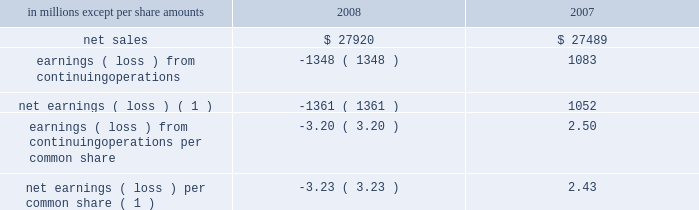The following unaudited pro forma information for the years ended december 31 , 2008 and 2007 pres- ents the results of operations of international paper as if the cbpr and central lewmar acquisitions , and the luiz antonio asset exchange , had occurred on january 1 , 2007 .
This pro forma information does not purport to represent international paper 2019s actual results of operations if the transactions described above would have occurred on january 1 , 2007 , nor is it necessarily indicative of future results .
In millions , except per share amounts 2008 2007 .
Earnings ( loss ) from continuing operations per common share ( 3.20 ) 2.50 net earnings ( loss ) per common share ( 1 ) ( 3.23 ) 2.43 ( 1 ) attributable to international paper company common share- holders .
Joint ventures in october 2007 , international paper and ilim holding s.a .
Announced the completion of the formation of a 50:50 joint venture to operate in russia as ilim group .
To form the joint venture , international paper purchased 50% ( 50 % ) of ilim holding s.a .
( ilim ) for approx- imately $ 620 million , including $ 545 million in cash and $ 75 million of notes payable , and contributed an additional $ 21 million in 2008 .
The company 2019s investment in ilim totaled approximately $ 465 mil- lion at december 31 , 2009 , which is approximately $ 190 million higher than the company 2019s share of the underlying net assets of ilim .
This basis difference primarily consists of the estimated fair value write-up of ilim plant , property and equipment of $ 150 million that is being amortized as a reduction of reported net income over the estimated remaining useful lives of the related assets , goodwill of $ 90 million and other basis differences of $ 50 million , including deferred taxes .
A key element of the proposed joint venture strategy is a long-term investment program in which the joint venture will invest , through cash from operations and additional borrowings by the joint venture , approximately $ 1.5 billion in ilim 2019s three mills over approximately five years .
This planned investment in the russian pulp and paper industry will be used to upgrade equipment , increase production capacity and allow for new high-value uncoated paper , pulp and corrugated packaging product development .
This capital expansion strategy is expected to be ini- tiated in the second half of 2010 , subject to ilim obtaining financing sufficient to fund the project .
Note 7 businesses held for sale , divestitures and impairments discontinued operations 2008 : during the fourth quarter of 2008 , the com- pany recorded pre-tax gains of $ 9 million ( $ 5 million after taxes ) for adjustments to reserves associated with the sale of discontinued operations .
During the first quarter of 2008 , the company recorded a pre-tax charge of $ 25 million ( $ 16 million after taxes ) related to the final settlement of a post- closing adjustment to the purchase price received by the company for the sale of its beverage packaging business , and a $ 3 million charge before taxes ( $ 2 million after taxes ) for 2008 operating losses related to certain wood products facilities .
2007 : during the fourth quarter of 2007 , the com- pany recorded a pre-tax charge of $ 9 million ( $ 6 mil- lion after taxes ) and a pre-tax credit of $ 4 million ( $ 3 million after taxes ) relating to adjustments to esti- mated losses on the sales of its beverage packaging and wood products businesses , respectively .
Addi- tionally , during the fourth quarter , a $ 4 million pre-tax charge ( $ 3 million after taxes ) was recorded for additional taxes associated with the sale of the company 2019s former weldwood of canada limited business .
During the third quarter of 2007 , the company com- pleted the sale of the remainder of its non-u.s .
Beverage packaging business .
During the second quarter of 2007 , the company recorded pre-tax charges of $ 6 million ( $ 4 million after taxes ) and $ 5 million ( $ 3 million after taxes ) relating to adjustments to estimated losses on the sales of its wood products and beverage packaging businesses , respectively .
During the first quarter of 2007 , the company recorded pre-tax credits of $ 21 million ( $ 9 million after taxes ) and $ 6 million ( $ 4 million after taxes ) relating to the sales of its wood products and kraft papers businesses , respectively .
In addition , a $ 15 million pre-tax charge ( $ 39 million after taxes ) was recorded for adjustments to the loss on the com- pletion of the sale of most of the beverage packaging business .
Finally , a pre-tax credit of approximately $ 10 million ( $ 6 million after taxes ) was recorded for refunds received from the canadian government of .
What was the ratio of the purchase composition international paper purchased 50% ( 50 % ) of ilim holding s.a for the cash to the notes notes parables? 
Computations: (545 / 75)
Answer: 7.26667. 